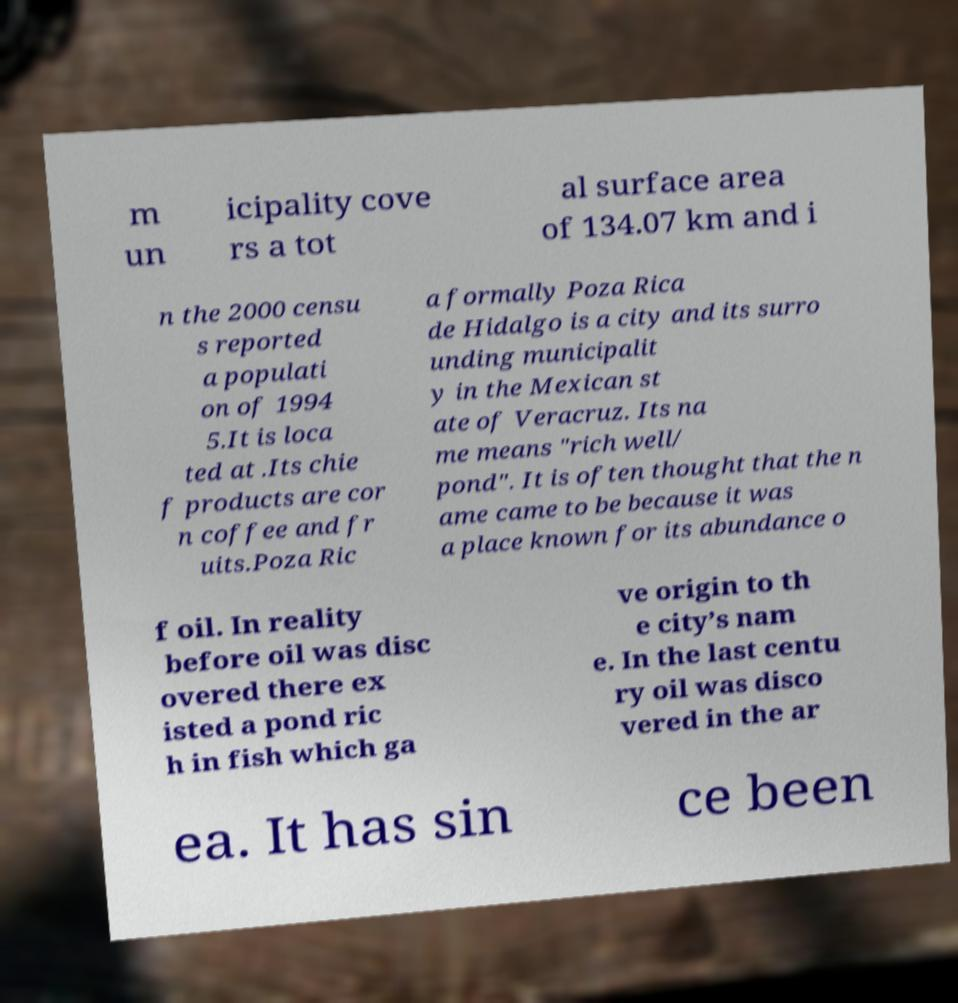Can you accurately transcribe the text from the provided image for me? m un icipality cove rs a tot al surface area of 134.07 km and i n the 2000 censu s reported a populati on of 1994 5.It is loca ted at .Its chie f products are cor n coffee and fr uits.Poza Ric a formally Poza Rica de Hidalgo is a city and its surro unding municipalit y in the Mexican st ate of Veracruz. Its na me means "rich well/ pond". It is often thought that the n ame came to be because it was a place known for its abundance o f oil. In reality before oil was disc overed there ex isted a pond ric h in fish which ga ve origin to th e city’s nam e. In the last centu ry oil was disco vered in the ar ea. It has sin ce been 